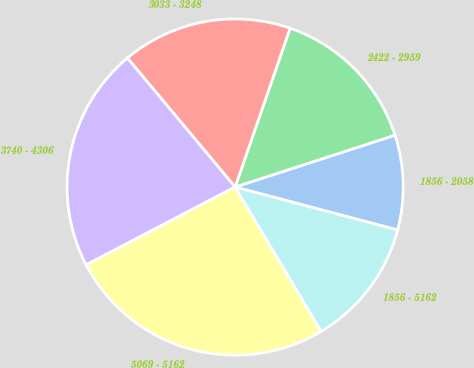Convert chart. <chart><loc_0><loc_0><loc_500><loc_500><pie_chart><fcel>1856 - 2058<fcel>2422 - 2959<fcel>3033 - 3248<fcel>3740 - 4306<fcel>5069 - 5162<fcel>1856 - 5162<nl><fcel>9.11%<fcel>14.7%<fcel>16.38%<fcel>21.6%<fcel>25.89%<fcel>12.33%<nl></chart> 